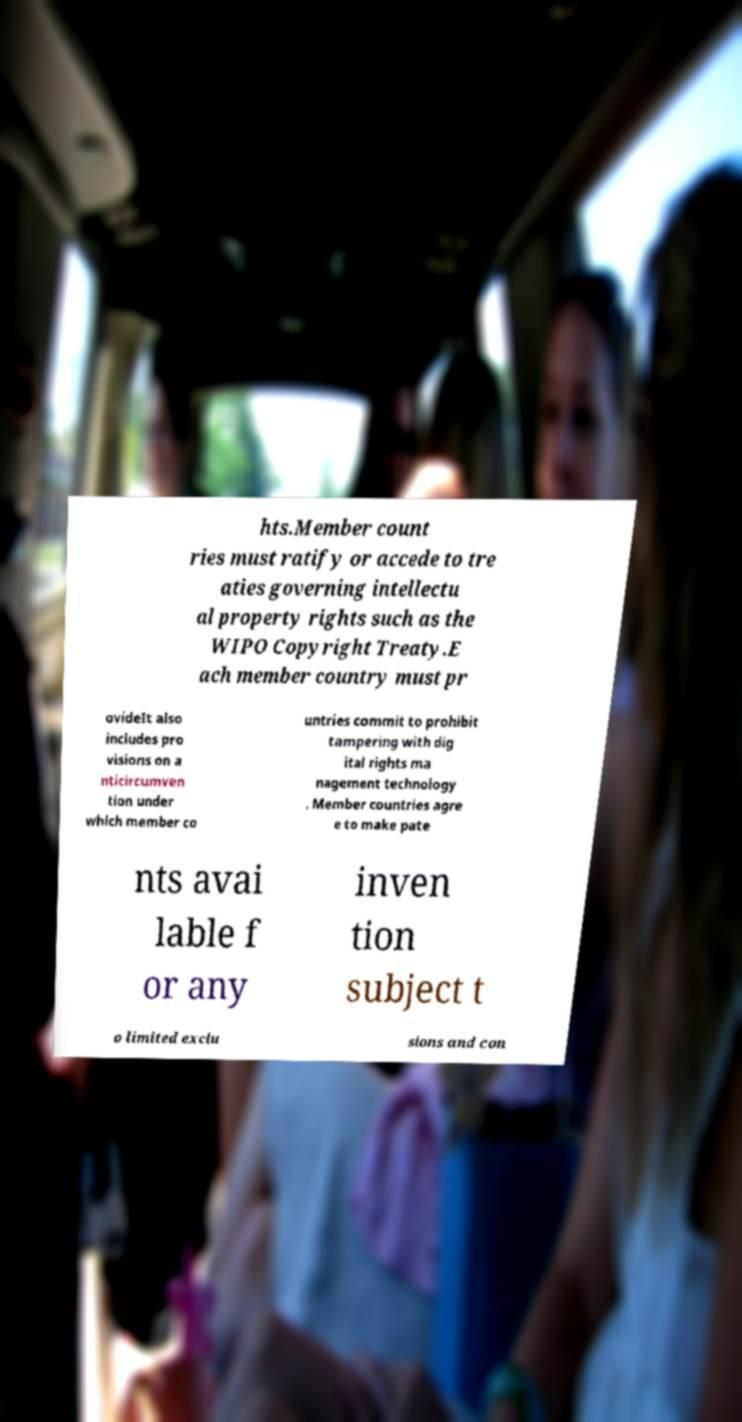What messages or text are displayed in this image? I need them in a readable, typed format. hts.Member count ries must ratify or accede to tre aties governing intellectu al property rights such as the WIPO Copyright Treaty.E ach member country must pr ovideIt also includes pro visions on a nticircumven tion under which member co untries commit to prohibit tampering with dig ital rights ma nagement technology . Member countries agre e to make pate nts avai lable f or any inven tion subject t o limited exclu sions and con 